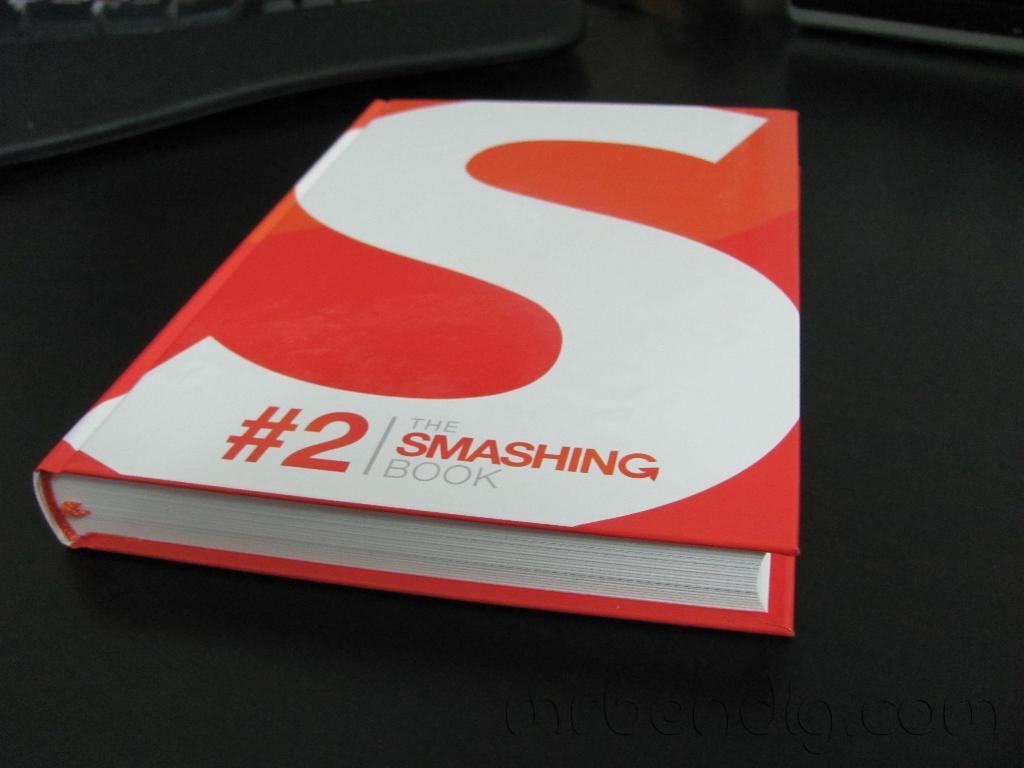What number is on the smashing book?
Provide a short and direct response. 2. What is the title of the book?
Offer a very short reply. The smashing book. 